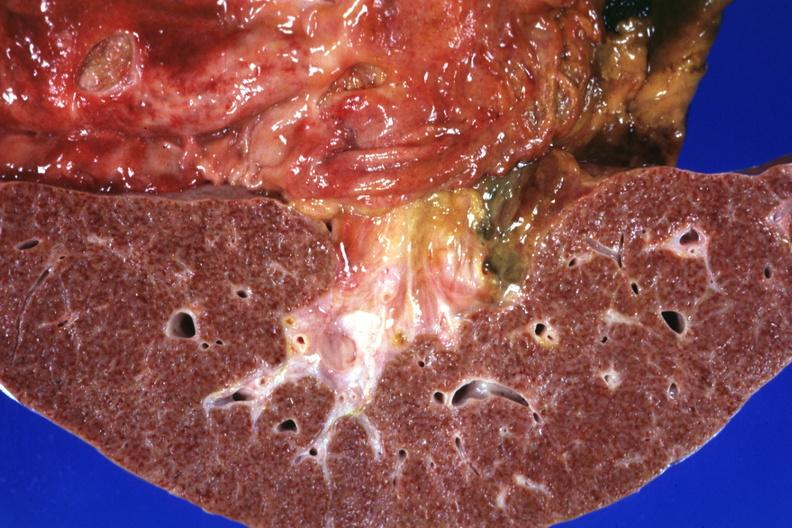s liver present?
Answer the question using a single word or phrase. Yes 